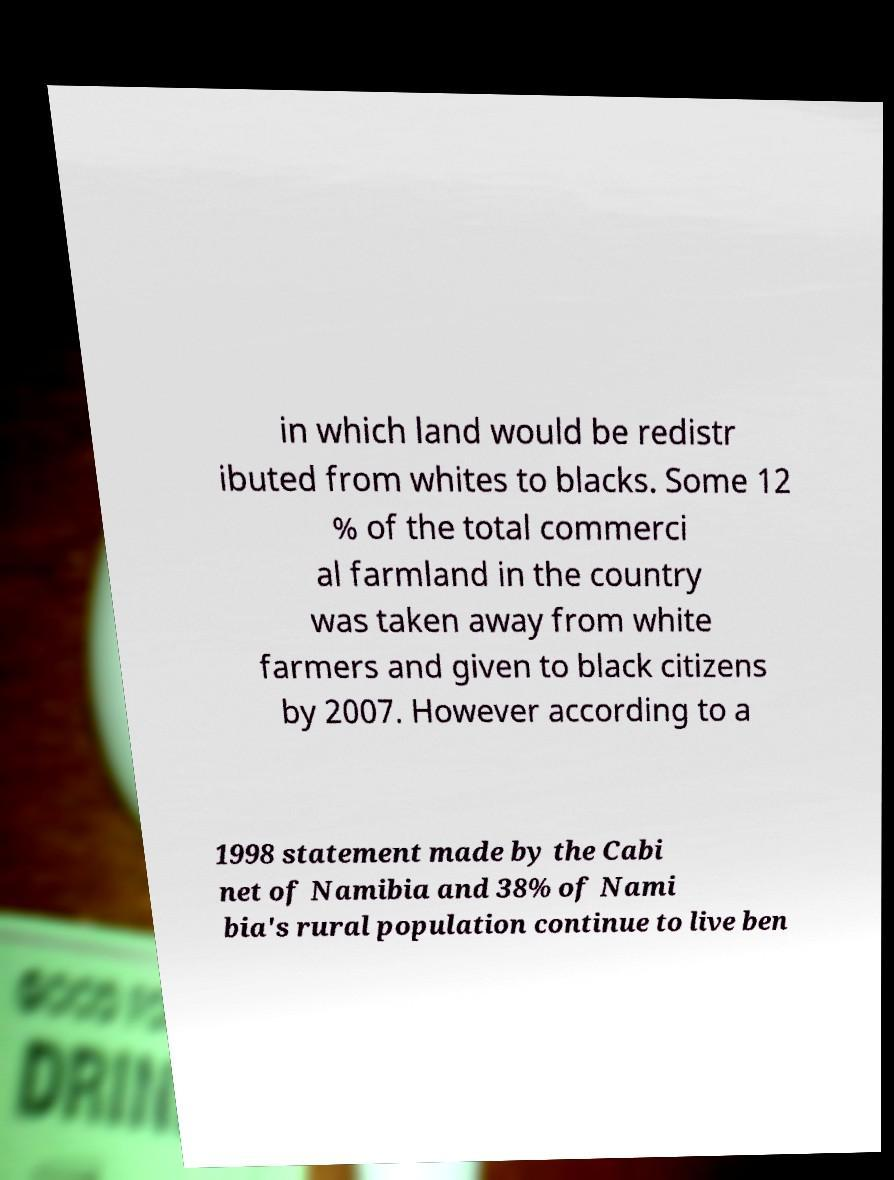Could you assist in decoding the text presented in this image and type it out clearly? in which land would be redistr ibuted from whites to blacks. Some 12 % of the total commerci al farmland in the country was taken away from white farmers and given to black citizens by 2007. However according to a 1998 statement made by the Cabi net of Namibia and 38% of Nami bia's rural population continue to live ben 